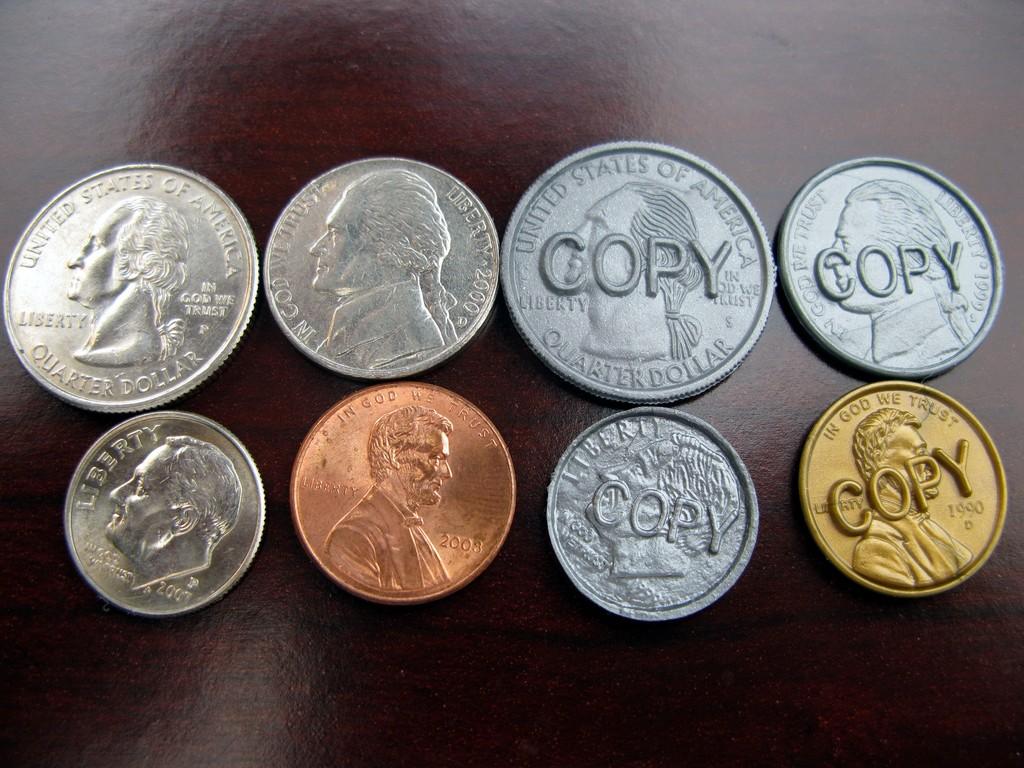How much money is there?
Ensure brevity in your answer.  82 cents. What is stamped over all of the fake coins?
Your answer should be very brief. Copy. 